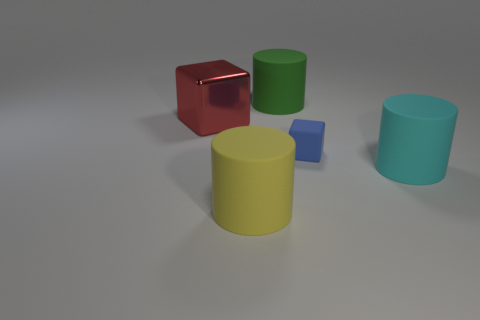There is a large cylinder that is behind the tiny blue thing; is it the same color as the cylinder that is right of the small blue block?
Your response must be concise. No. There is a big cylinder that is on the left side of the big rubber cylinder behind the big cylinder on the right side of the blue matte object; what is it made of?
Your answer should be very brief. Rubber. Are there any red metal objects that have the same size as the green matte cylinder?
Provide a succinct answer. Yes. There is a green object that is the same size as the yellow rubber cylinder; what is it made of?
Offer a very short reply. Rubber. What is the shape of the big cyan object that is in front of the green cylinder?
Ensure brevity in your answer.  Cylinder. Are the cube that is left of the large yellow cylinder and the cube that is in front of the red cube made of the same material?
Your response must be concise. No. How many large cyan things have the same shape as the big yellow matte thing?
Make the answer very short. 1. How many things are large objects or big cylinders that are on the right side of the tiny rubber block?
Ensure brevity in your answer.  4. What is the material of the cyan cylinder?
Offer a very short reply. Rubber. What material is the other object that is the same shape as the tiny blue rubber thing?
Your response must be concise. Metal. 